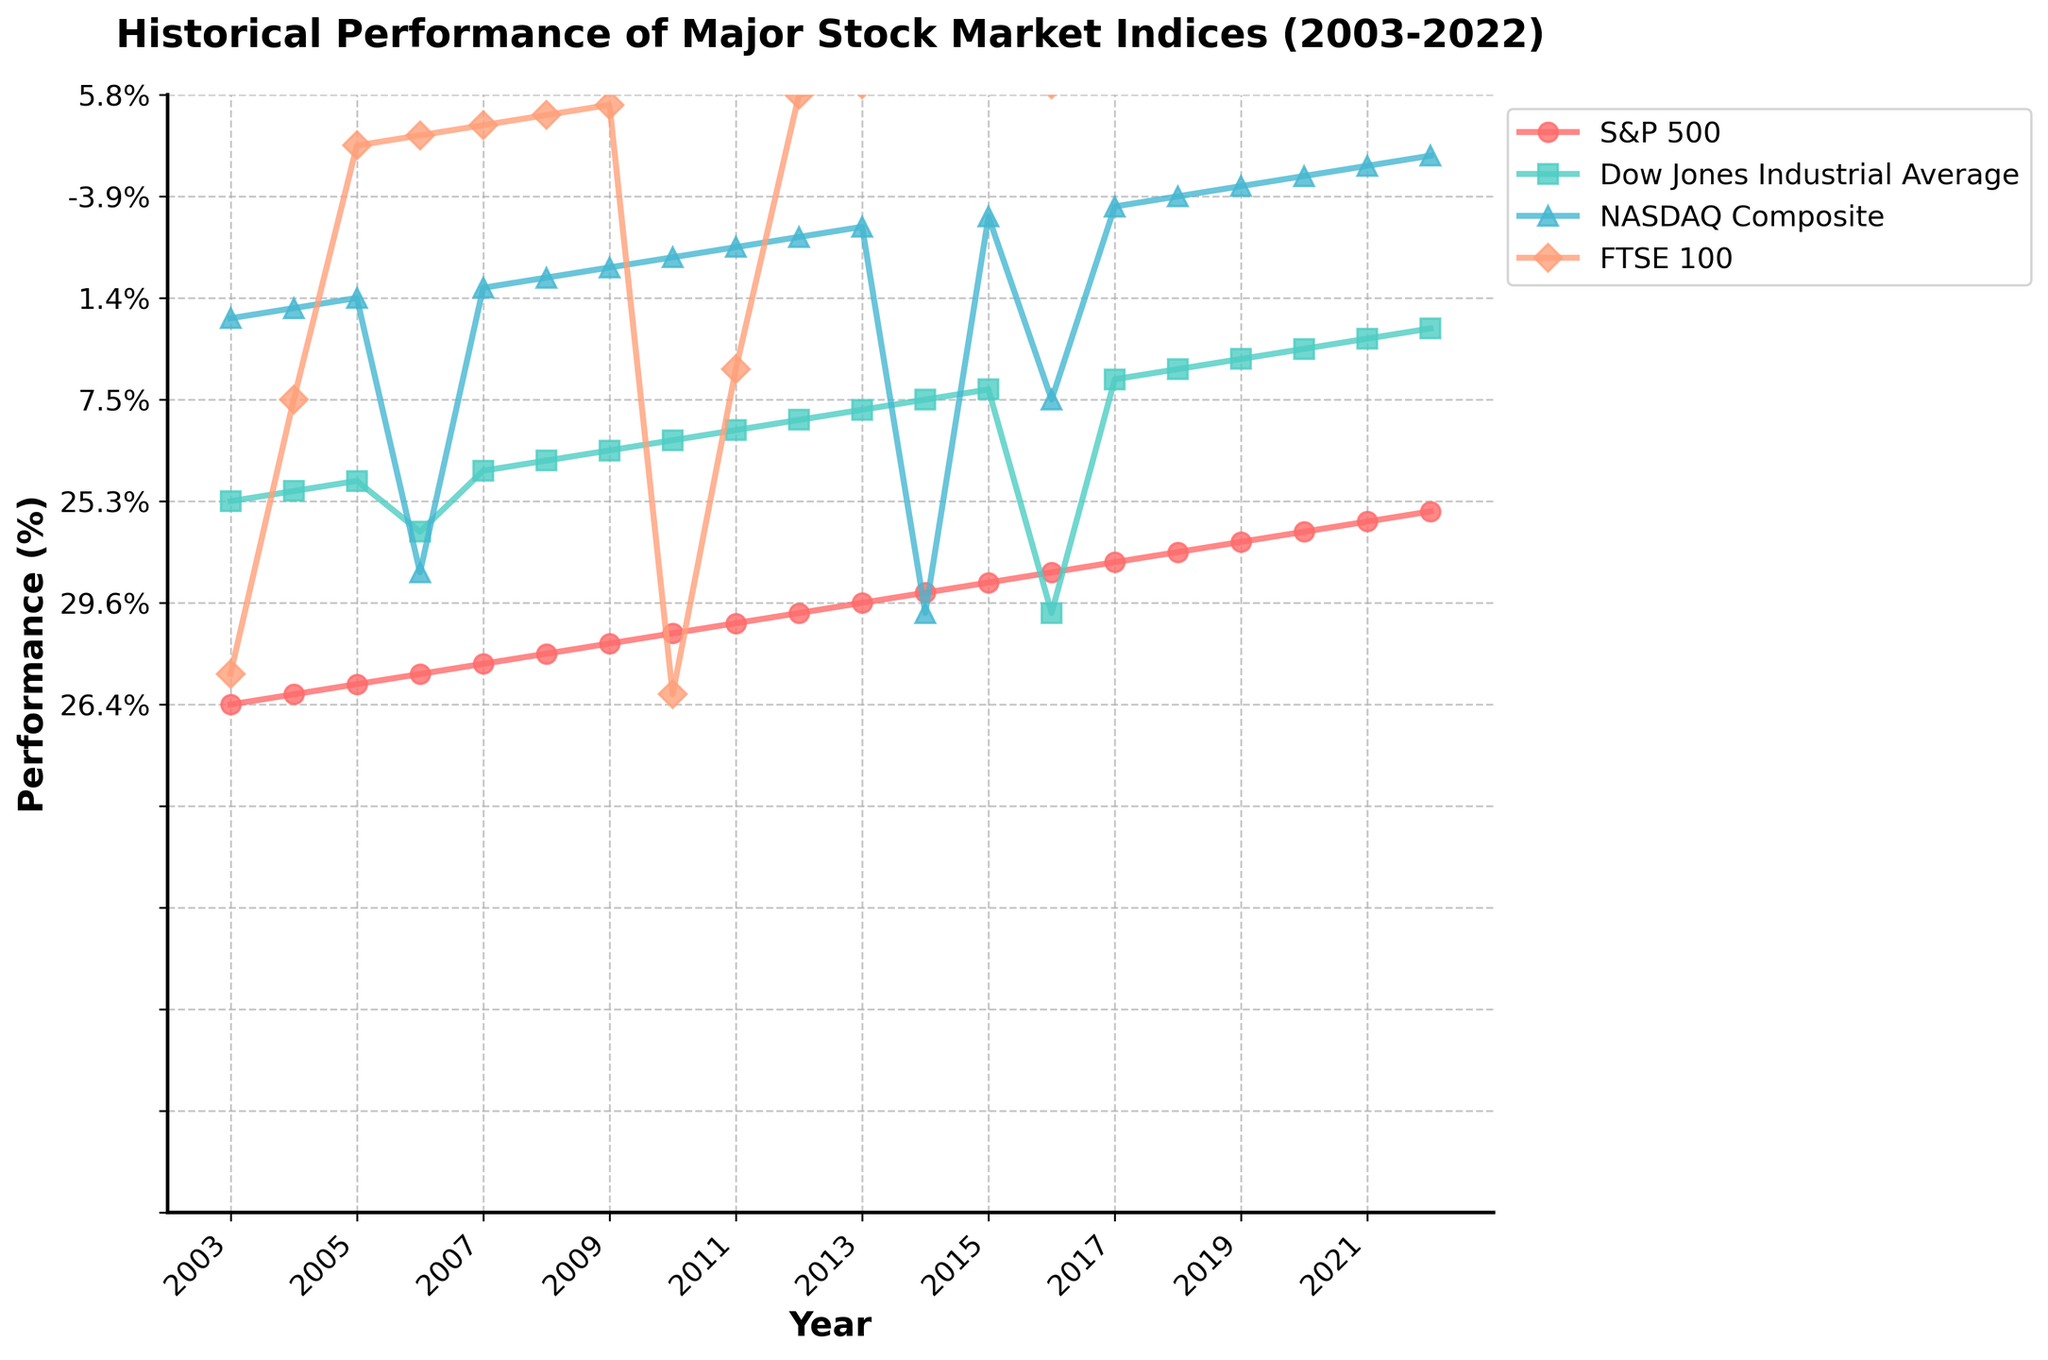What was the worst performance year for the S&P 500? Look at the S&P 500 line and find the lowest point. The lowest point is in 2008, where it shows -38.5%.
Answer: 2008 Which index had the highest performance in 2017? Compare the values of all four indices in 2017. The highest value is for NASDAQ Composite with 28.2%.
Answer: NASDAQ Composite Between 2008 and 2009, which index had the highest improvement? Calculate the difference for each index between 2008 and 2009. The improvements are S&P 500: 62%, Dow Jones: 52.6%, NASDAQ Composite: 84.4%, FTSE 100: 53.4%. NASDAQ Composite had the highest improvement.
Answer: NASDAQ Composite What was the average performance of the FTSE 100 in 2010 and 2011? Sum the performances for FTSE 100 in 2010 and 2011 (9% + -5.6%) and divide by 2. The average performance is (9 - 5.6) / 2 = 1.7%.
Answer: 1.7% Is there a year where all four indices show positive performance? Check the values year by year. In 2004, the indices S&P 500, Dow Jones, NASDAQ, and FTSE 100 all show positive values.
Answer: 2004 Which index showed the most consistent performance over the 20 years? Review the lines of each index for stability and minimal fluctuation. The Dow Jones Industrial Average appears most consistent, with fewer extreme ups and downs.
Answer: Dow Jones Industrial Average What is the performance difference between the S&P 500 and NASDAQ Composite in 2020? Find the values for the S&P 500 (16.3%) and NASDAQ Composite (43.6%) in 2020. The difference is 43.6% - 16.3% = 27.3%.
Answer: 27.3% Which year had the largest negative performance for the NASDAQ Composite, and what was the value? Look for the lowest point on NASDAQ Composite's line. It's in 2008 with -40.5%.
Answer: 2008, -40.5% Was there any year where only one index performed negatively, and which one? In 2005, Dow Jones Industrial Average performed negatively (-0.6%), while the other indices were positive.
Answer: 2005, Dow Jones Industrial Average How does the performance of FTSE 100 in 2022 compare to its performance in 2020? Look at the values for FTSE 100 in 2022 (0.9%) and in 2020 (-14.3%) and compare them. FTSE 100 improved by 15.2% from 2020 to 2022.
Answer: Improved by 15.2% 